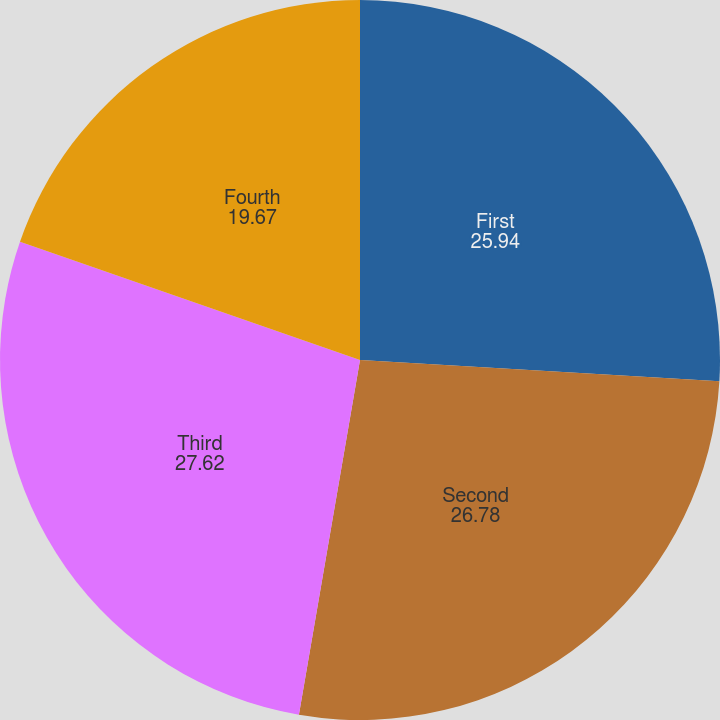Convert chart to OTSL. <chart><loc_0><loc_0><loc_500><loc_500><pie_chart><fcel>First<fcel>Second<fcel>Third<fcel>Fourth<nl><fcel>25.94%<fcel>26.78%<fcel>27.62%<fcel>19.67%<nl></chart> 